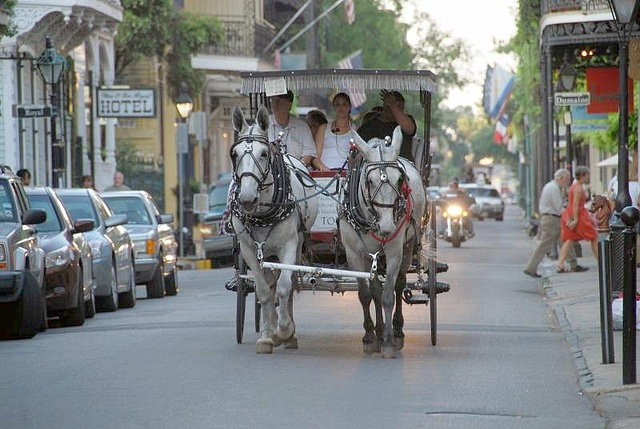Describe the objects in this image and their specific colors. I can see horse in black, gray, darkgray, and maroon tones, horse in black, gray, darkgray, and lightgray tones, car in black, gray, and darkgray tones, car in black, gray, and darkgray tones, and car in black, gray, darkgray, and lightgray tones in this image. 